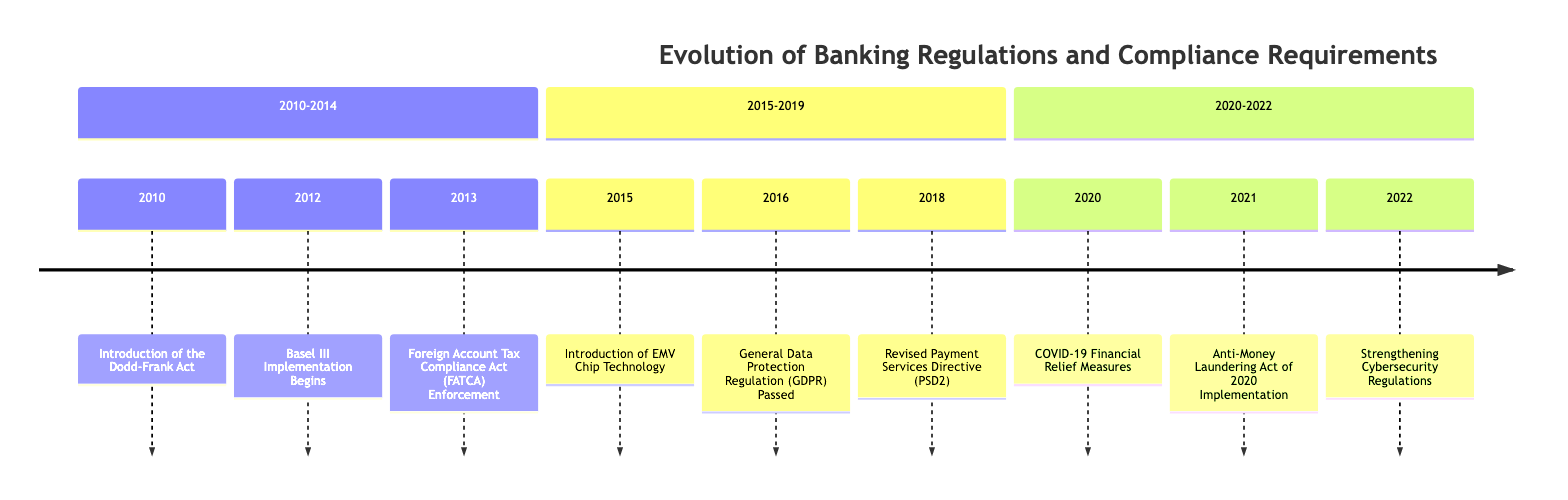What year was the Dodd-Frank Act introduced? The Dodd-Frank Act is mentioned as being introduced in the year 2010. This information is located at the very beginning of the timeline.
Answer: 2010 What event occurred in 2016? In 2016, the General Data Protection Regulation (GDPR) was passed. This is found in the section that covers the years 2015-2019.
Answer: General Data Protection Regulation (GDPR) Passed How many events were listed in the timeline for the years 2010 to 2014? The events listed from 2010 to 2014 include three distinct events: the Dodd-Frank Act in 2010, Basel III implementation in 2012, and FATCA enforcement in 2013. Therefore, the total number of events in this timeframe is three.
Answer: 3 Which regulation strengthened bank capital requirements? The Basel III Implementation which began in 2012 aimed to strengthen bank capital requirements. This is clearly identified among the events listed in the timeline.
Answer: Basel III Implementation Begins What development regarding compliance was significant in 2021? The implementation of the Anti-Money Laundering Act of 2020 is significant as it introduced new reporting requirements. This event is situated in the 2020-2022 section.
Answer: Anti-Money Laundering Act of 2020 Implementation Which event in the timeline is related to cybersecurity? The event related to cybersecurity is the strengthening of cybersecurity regulations that occurred in 2022. This event is noted at the end of the timeline.
Answer: Strengthening Cybersecurity Regulations Which act requires US persons to report foreign financial accounts? The Foreign Account Tax Compliance Act (FATCA) enforced in 2013 requires US persons to report their financial accounts held outside of the US. This can be found in the 2013 entry of the timeline.
Answer: Foreign Account Tax Compliance Act (FATCA) Enforcement What was a key response by banks during the COVID-19 pandemic? A key response was the introduction of financial relief measures to support customers during the pandemic, noted in the 2020 event description. This emphasizes the regulatory adaptations made in response to the crisis.
Answer: COVID-19 Financial Relief Measures What timeline section includes EMV Chip Technology? The introduction of EMV Chip Technology is included in the section covering the years 2015-2019. This information helps identify the technological advancements during that period.
Answer: 2015-2019 